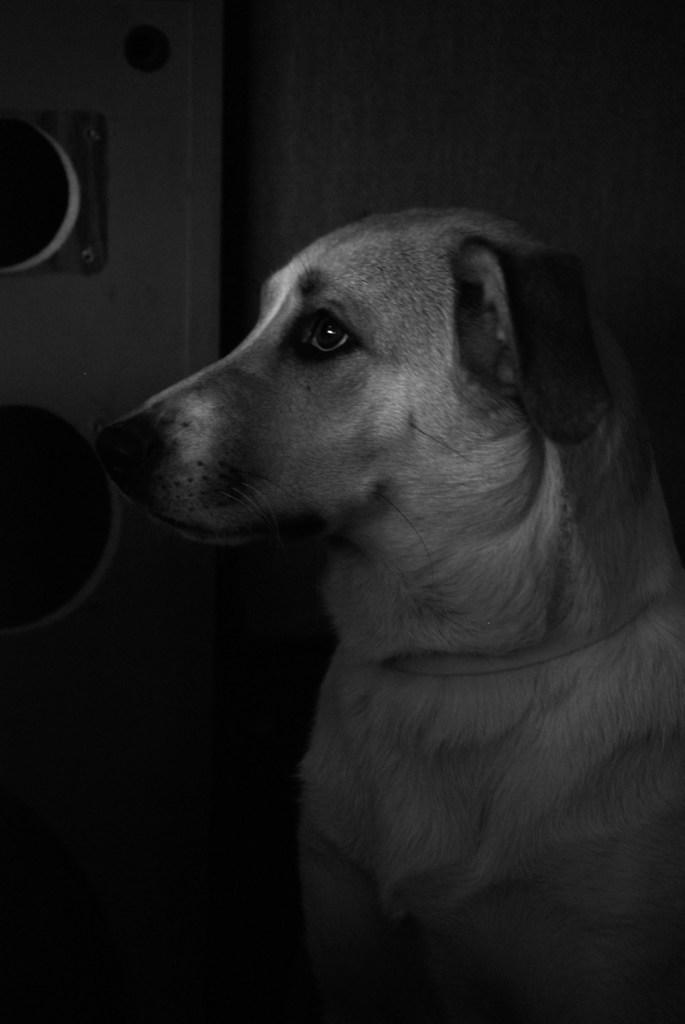What is present in the image? There is a wall in the image. What is the color scheme of the image? The image is black and white. How many corks can be seen on the wall in the image? There are no corks present on the wall in the image. What is the interest rate depicted on the wall in the image? There is no interest rate or financial information present on the wall in the image. 